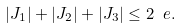Convert formula to latex. <formula><loc_0><loc_0><loc_500><loc_500>| J _ { 1 } | + | J _ { 2 } | + | J _ { 3 } | \leq 2 \ e .</formula> 